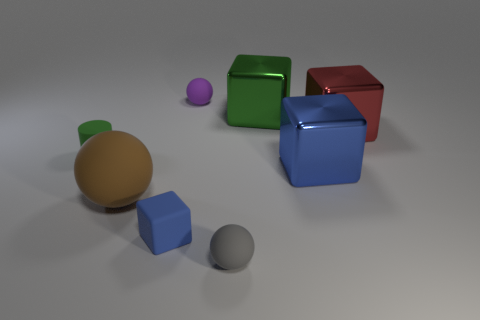Which object in the image is the closest to the camera? The object closest to the camera appears to be the small blue cube which is sitting on the ground. 